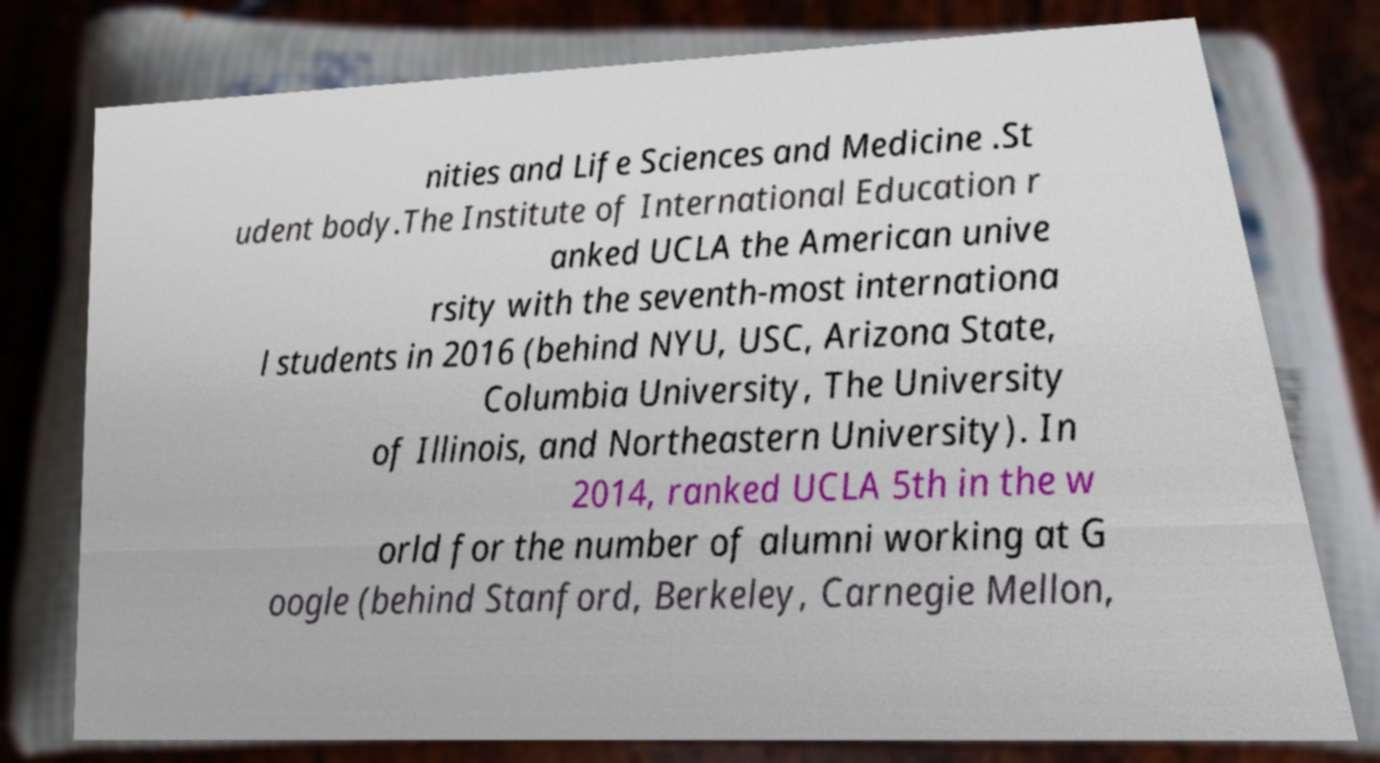There's text embedded in this image that I need extracted. Can you transcribe it verbatim? nities and Life Sciences and Medicine .St udent body.The Institute of International Education r anked UCLA the American unive rsity with the seventh-most internationa l students in 2016 (behind NYU, USC, Arizona State, Columbia University, The University of Illinois, and Northeastern University). In 2014, ranked UCLA 5th in the w orld for the number of alumni working at G oogle (behind Stanford, Berkeley, Carnegie Mellon, 